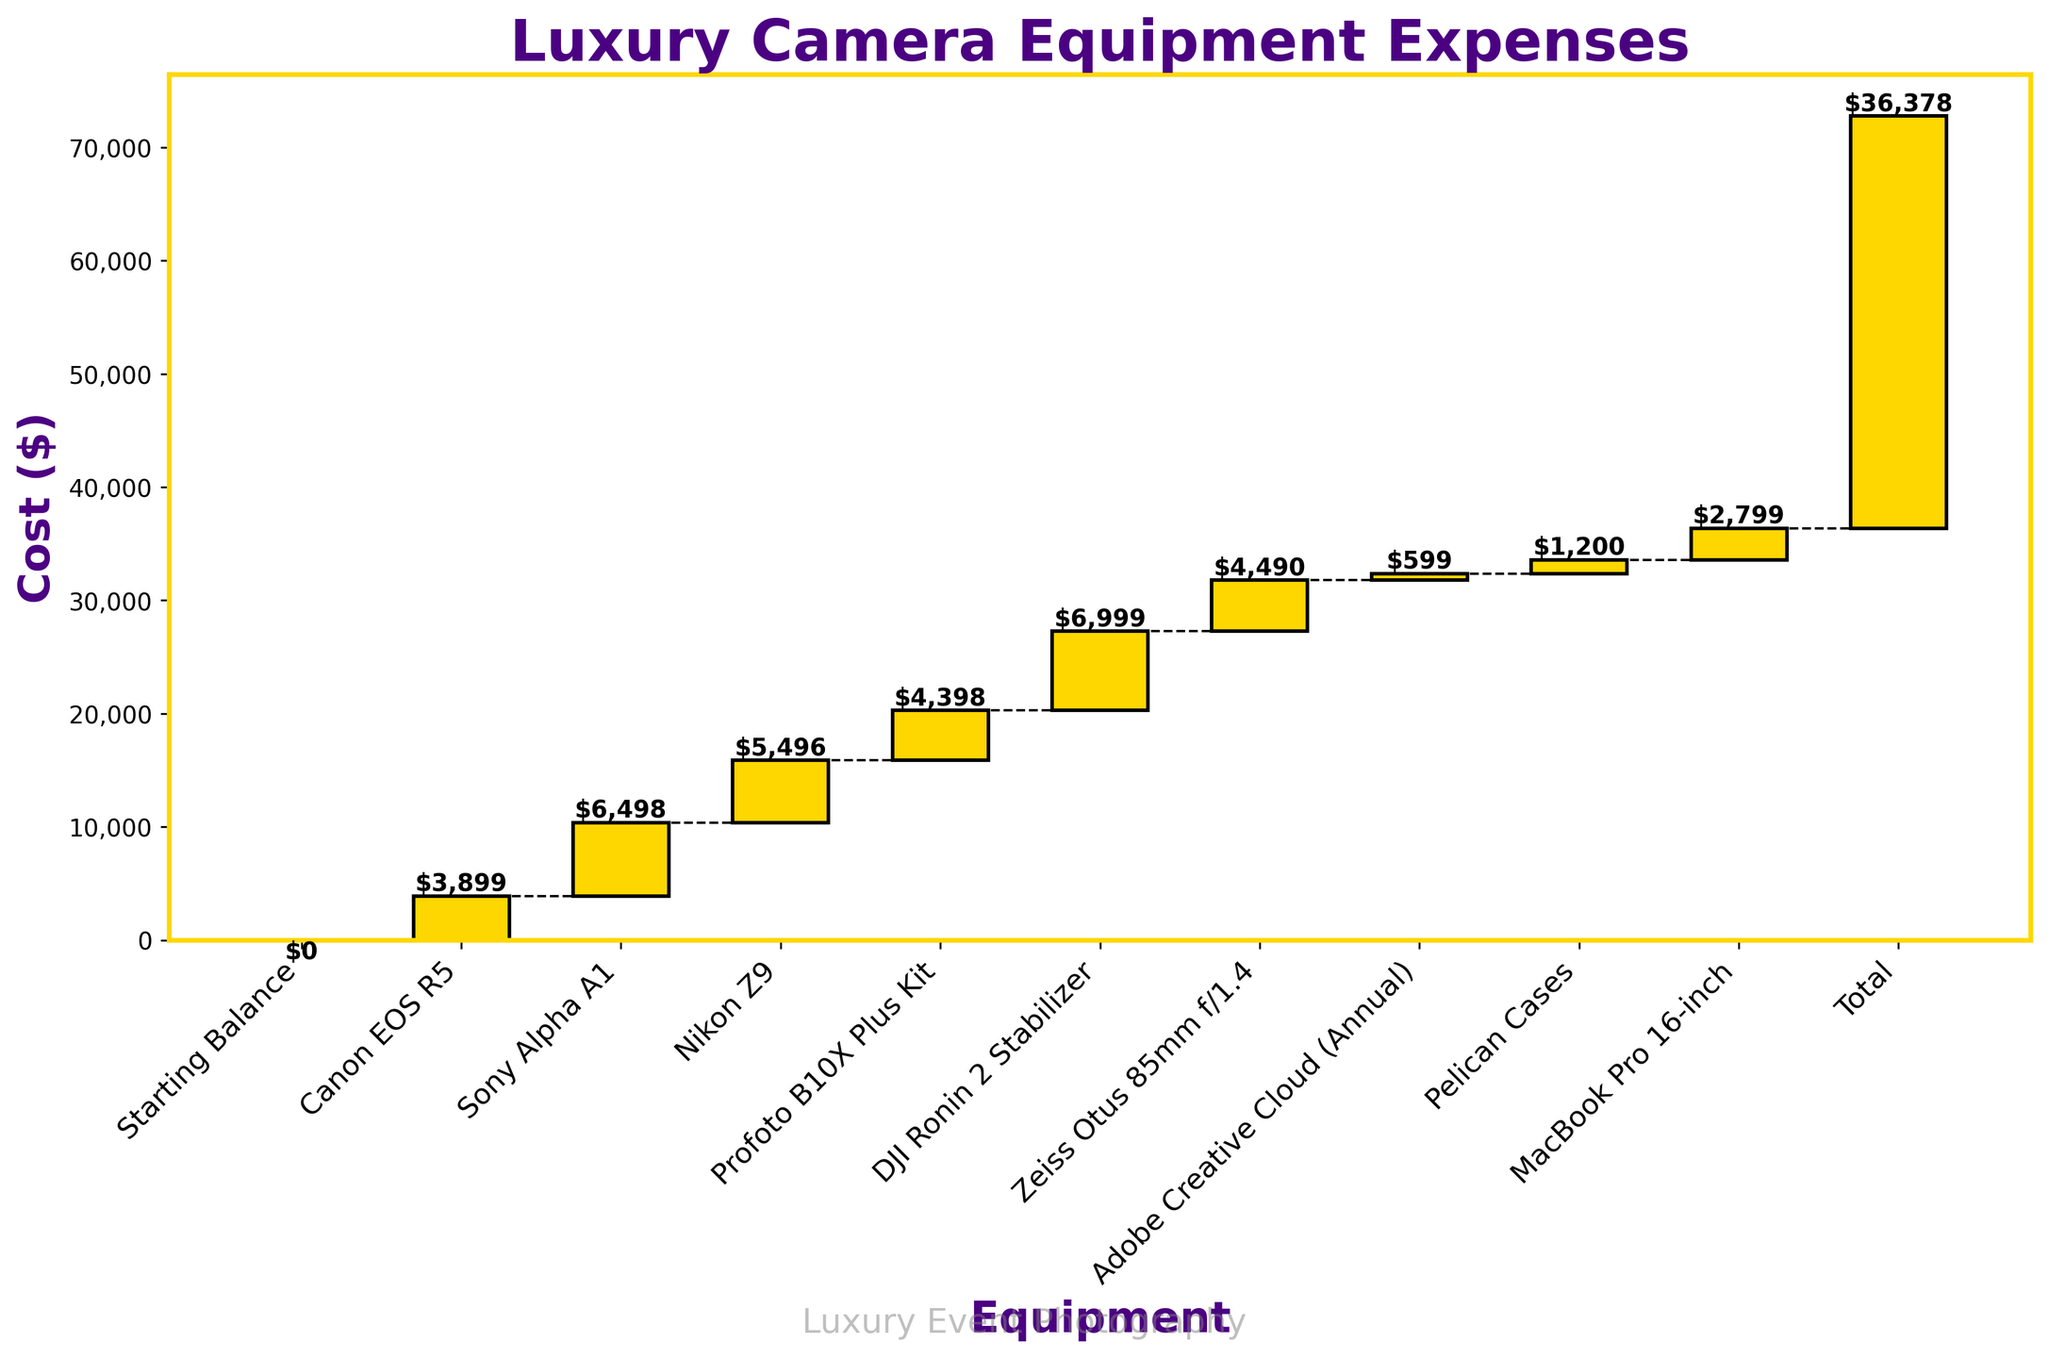what is the title of the chart? The title can be seen at the top of the chart. It emphasizes the nature of the expenses being detailed.
Answer: "Luxury Camera Equipment Expenses" What is the cost of the Canon EOS R5? Look at the vertical bar representing the Canon EOS R5. The number at the top of the bar indicates the expense.
Answer: $3,899 How much did you spend on the Sony Alpha A1 compared to the Nikon Z9? Identify the bars for the Sony Alpha A1 and Nikon Z9. Compare the numbers shown at the top of each bar indicating their costs.
Answer: Sony Alpha A1 costs $6,498 and Nikon Z9 costs $5,496 What is the cumulative total after buying the DJI Ronin 2 Stabilizer? Sum the costs of all entries up to and including the DJI Ronin 2 Stabilizer. Add $3,899 + $6,498 + $5,496 + $4,398 + $6,999.
Answer: $27,290 What expense category contributes the least amount? Scan the bars and identify the one with the lowest value. Check the top of the bar for the value.
Answer: Adobe Creative Cloud (Annual) with $599 Which product is purchased immediately after the Nikon Z9? Identify the position of the Nikon Z9 in the sequence and look at the next bar in the chart.
Answer: Profoto B10X Plus Kit How many equipment items are listed excluding total balances? Count the number of labels/bars, subtracting those related to starting and total balances.
Answer: 8 What is the total expenditure on Zeiss Otus 85mm f/1.4 and the Pelican Cases? Look at the individual costs of Zeiss Otus 85mm f/1.4 and Pelican Cases and sum them. $4,490 + $1,200
Answer: $5,690 How does the cost of the MacBook Pro 16-inch compare to the Profoto B10X Plus Kit? Compare the numbers at the top of the bars representing the MacBook Pro 16-inch and Profoto B10X Plus Kit.
Answer: MacBook Pro 16-inch is less expensive than the Profoto B10X Plus Kit At which point do the cumulative expenses reach approximately $25,000? Check the cumulative totals at the top of the bars until you find the closest value to $25,000. This occurs somewhere between cumulative $21,291 and $27,290.
Answer: After purchasing DJI Ronin 2 Stabilizer 